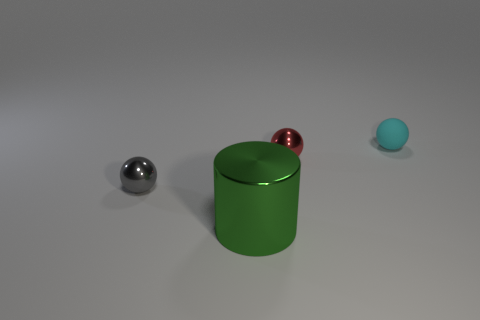Add 4 red things. How many objects exist? 8 Subtract all balls. How many objects are left? 1 Subtract all cylinders. Subtract all small gray metal objects. How many objects are left? 2 Add 1 gray spheres. How many gray spheres are left? 2 Add 1 big objects. How many big objects exist? 2 Subtract 0 blue cylinders. How many objects are left? 4 